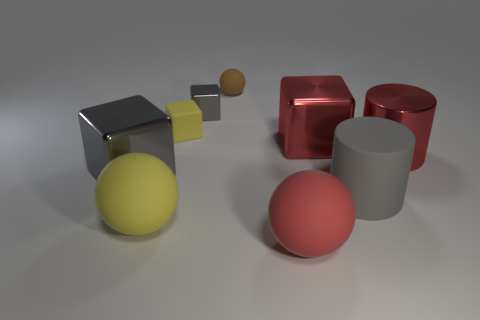Subtract all shiny cubes. How many cubes are left? 1 Add 1 tiny purple shiny balls. How many objects exist? 10 Subtract all yellow spheres. How many spheres are left? 2 Subtract all cubes. How many objects are left? 5 Add 8 brown things. How many brown things are left? 9 Add 5 gray matte cylinders. How many gray matte cylinders exist? 6 Subtract 1 gray cylinders. How many objects are left? 8 Subtract 1 cylinders. How many cylinders are left? 1 Subtract all green cylinders. Subtract all blue cubes. How many cylinders are left? 2 Subtract all red cylinders. How many yellow cubes are left? 1 